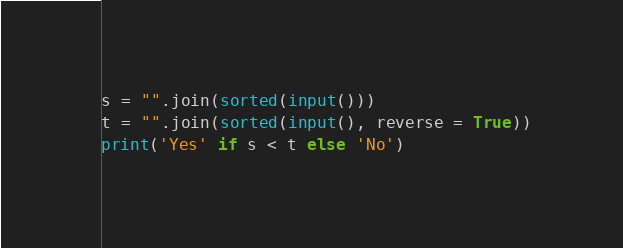<code> <loc_0><loc_0><loc_500><loc_500><_Python_>s = "".join(sorted(input()))
t = "".join(sorted(input(), reverse = True))
print('Yes' if s < t else 'No')</code> 